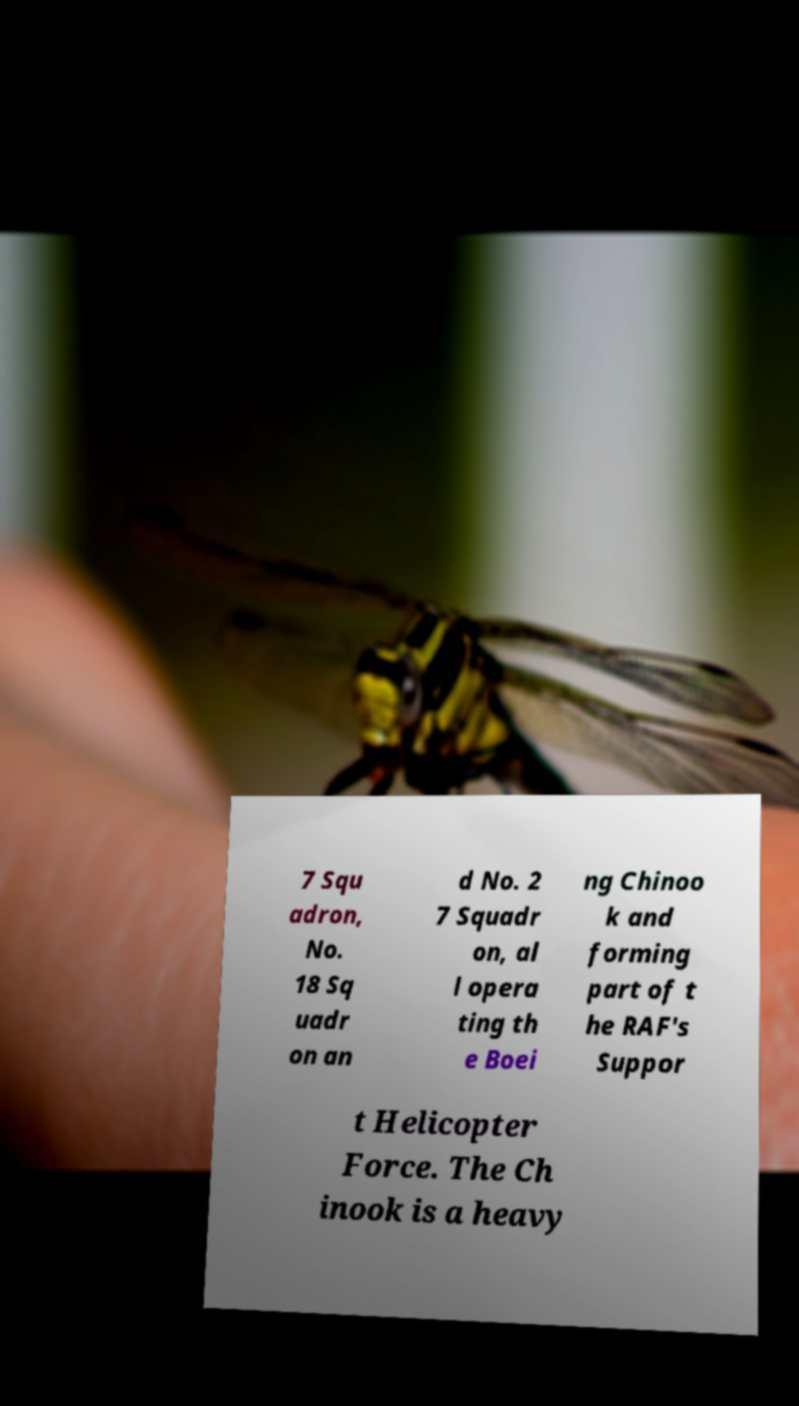Please read and relay the text visible in this image. What does it say? 7 Squ adron, No. 18 Sq uadr on an d No. 2 7 Squadr on, al l opera ting th e Boei ng Chinoo k and forming part of t he RAF's Suppor t Helicopter Force. The Ch inook is a heavy 